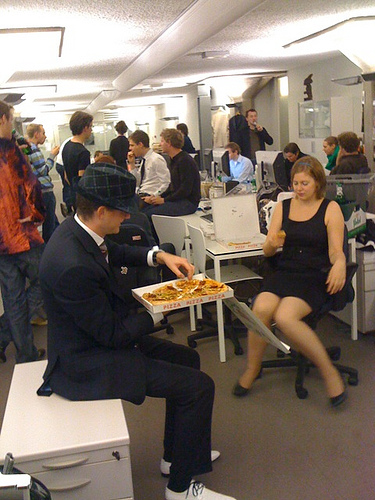<image>What is the woman doing? I'm not sure what the woman is doing. She could be eating, sitting, looking down, or texting. What is the woman doing? I don't know what the woman is doing. She can be doing different activities such as eating, sitting, looking down or texting. 